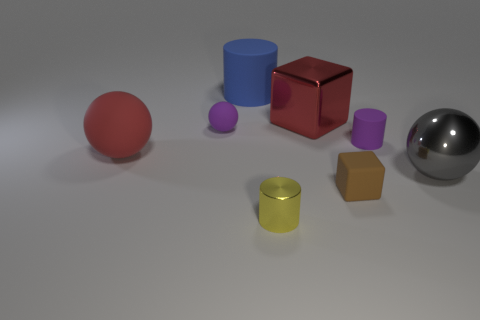Is the material of the sphere to the right of the small ball the same as the red thing left of the big blue matte object?
Give a very brief answer. No. There is a small brown block; how many large red cubes are on the right side of it?
Ensure brevity in your answer.  0. How many purple objects are matte things or large blocks?
Offer a terse response. 2. What material is the blue cylinder that is the same size as the red metallic block?
Provide a short and direct response. Rubber. What shape is the matte thing that is to the right of the big matte ball and in front of the small rubber cylinder?
Provide a short and direct response. Cube. The block that is the same size as the blue thing is what color?
Provide a short and direct response. Red. Do the block that is in front of the big shiny ball and the red thing that is left of the yellow cylinder have the same size?
Make the answer very short. No. There is a cylinder that is on the left side of the tiny cylinder that is on the left side of the small rubber block that is to the left of the large gray object; what size is it?
Offer a very short reply. Large. There is a red thing on the right side of the purple rubber ball on the left side of the small rubber cylinder; what shape is it?
Keep it short and to the point. Cube. Does the rubber cylinder that is right of the yellow thing have the same color as the large metallic block?
Provide a succinct answer. No. 